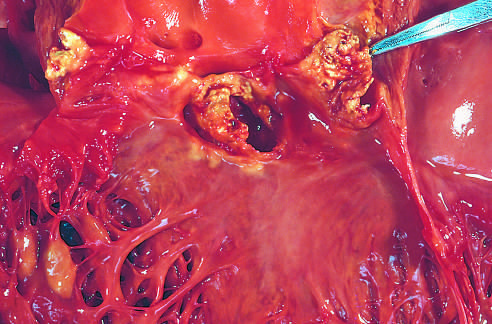what is acute endocarditis caused by?
Answer the question using a single word or phrase. Staphylococcus aureus on a congenitally bicuspid aortic valve with extensive cuspal destruction and ring abscess 